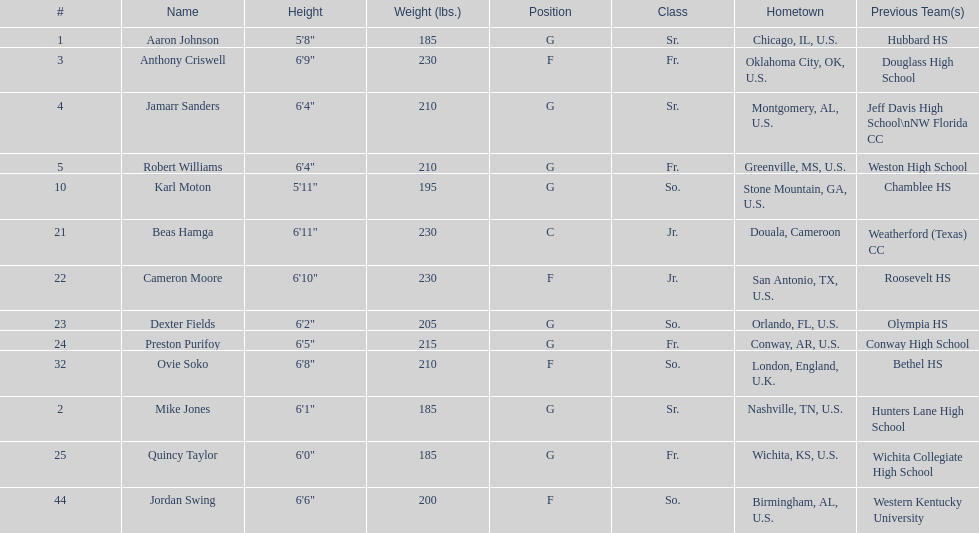How many forwards are there in total on the team? 4. 